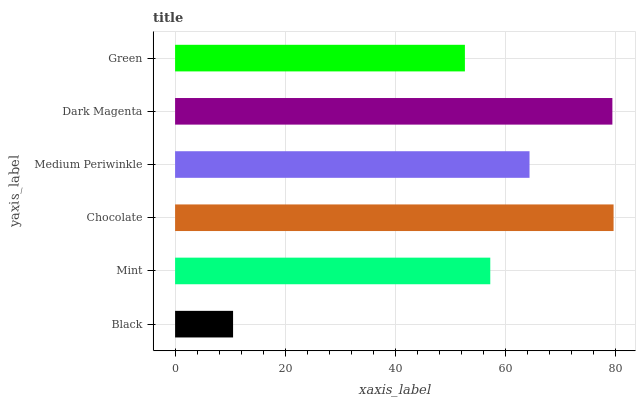Is Black the minimum?
Answer yes or no. Yes. Is Chocolate the maximum?
Answer yes or no. Yes. Is Mint the minimum?
Answer yes or no. No. Is Mint the maximum?
Answer yes or no. No. Is Mint greater than Black?
Answer yes or no. Yes. Is Black less than Mint?
Answer yes or no. Yes. Is Black greater than Mint?
Answer yes or no. No. Is Mint less than Black?
Answer yes or no. No. Is Medium Periwinkle the high median?
Answer yes or no. Yes. Is Mint the low median?
Answer yes or no. Yes. Is Chocolate the high median?
Answer yes or no. No. Is Dark Magenta the low median?
Answer yes or no. No. 